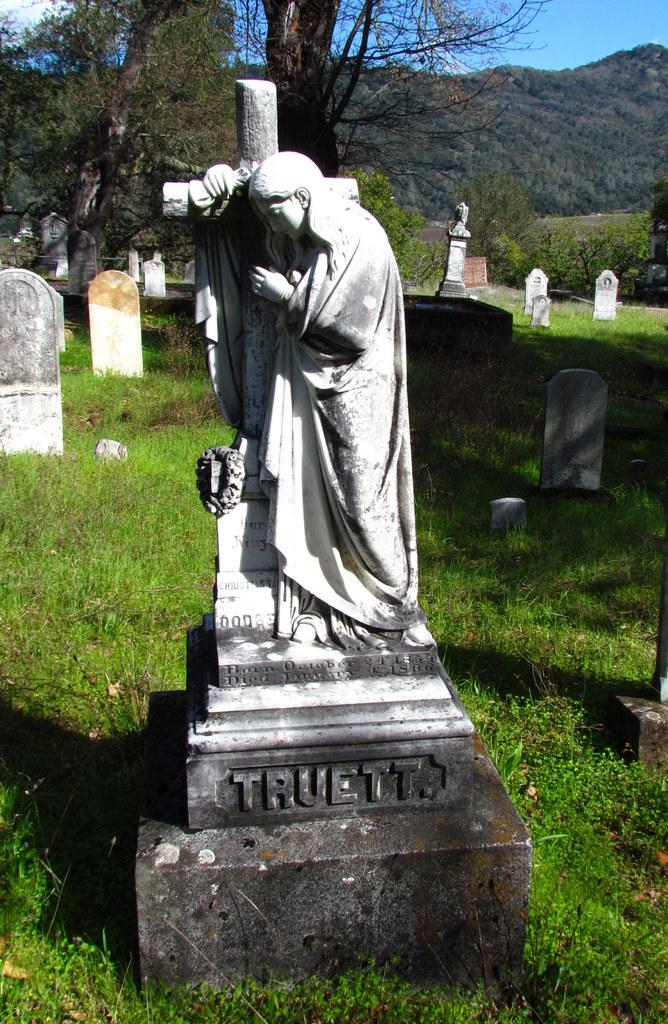What type of objects can be seen in the image? There are statues in the image. What colors are the statues? The statues are in white and black colors. What can be seen in the background of the image? Cemeteries, trees, and mountains are visible in the background. What type of vegetation is present in the image? There is green grass in the image. What is the color of the sky in the image? The sky is blue. What type of linen is used to cover the statues in the image? There is no linen present in the image; the statues are not covered. Can you tell me the account balance of the person who took the picture? There is no information about the person who took the picture or their account balance in the image. 